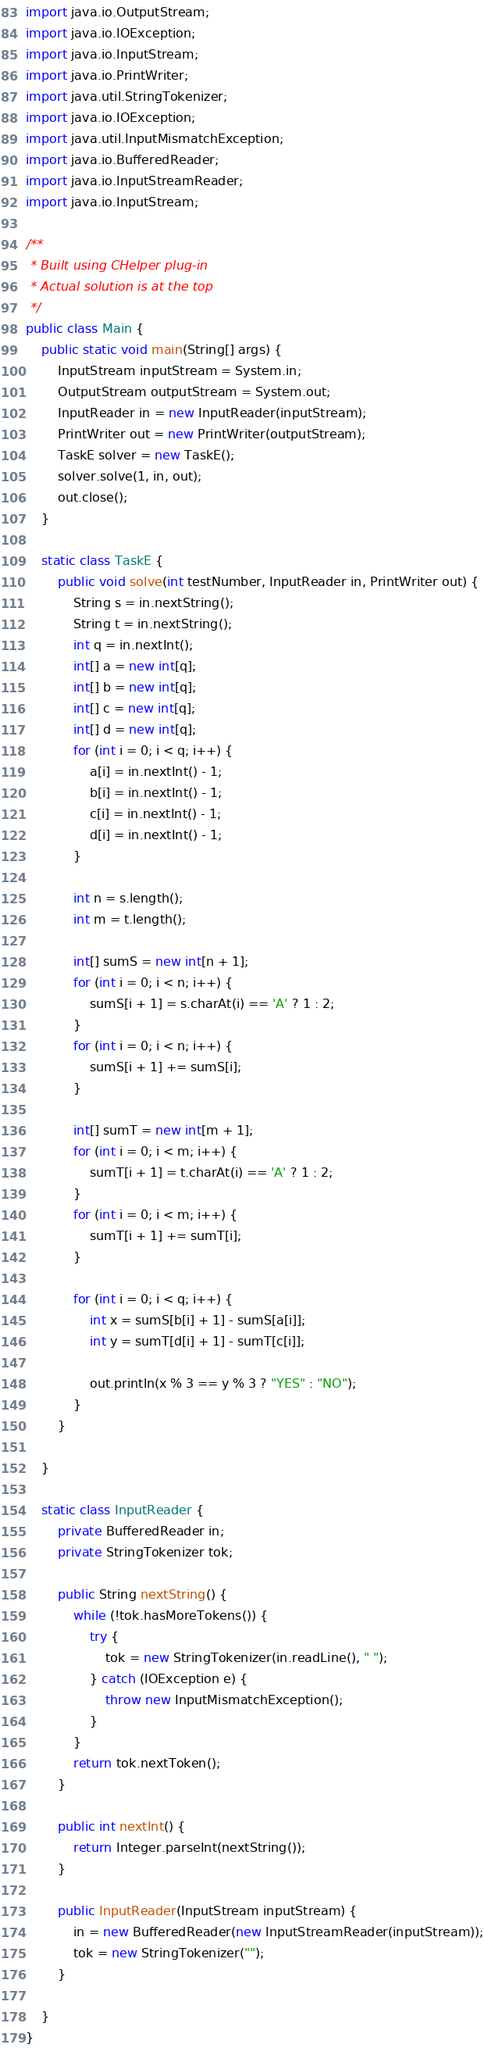<code> <loc_0><loc_0><loc_500><loc_500><_Java_>import java.io.OutputStream;
import java.io.IOException;
import java.io.InputStream;
import java.io.PrintWriter;
import java.util.StringTokenizer;
import java.io.IOException;
import java.util.InputMismatchException;
import java.io.BufferedReader;
import java.io.InputStreamReader;
import java.io.InputStream;

/**
 * Built using CHelper plug-in
 * Actual solution is at the top
 */
public class Main {
    public static void main(String[] args) {
        InputStream inputStream = System.in;
        OutputStream outputStream = System.out;
        InputReader in = new InputReader(inputStream);
        PrintWriter out = new PrintWriter(outputStream);
        TaskE solver = new TaskE();
        solver.solve(1, in, out);
        out.close();
    }

    static class TaskE {
        public void solve(int testNumber, InputReader in, PrintWriter out) {
            String s = in.nextString();
            String t = in.nextString();
            int q = in.nextInt();
            int[] a = new int[q];
            int[] b = new int[q];
            int[] c = new int[q];
            int[] d = new int[q];
            for (int i = 0; i < q; i++) {
                a[i] = in.nextInt() - 1;
                b[i] = in.nextInt() - 1;
                c[i] = in.nextInt() - 1;
                d[i] = in.nextInt() - 1;
            }

            int n = s.length();
            int m = t.length();

            int[] sumS = new int[n + 1];
            for (int i = 0; i < n; i++) {
                sumS[i + 1] = s.charAt(i) == 'A' ? 1 : 2;
            }
            for (int i = 0; i < n; i++) {
                sumS[i + 1] += sumS[i];
            }

            int[] sumT = new int[m + 1];
            for (int i = 0; i < m; i++) {
                sumT[i + 1] = t.charAt(i) == 'A' ? 1 : 2;
            }
            for (int i = 0; i < m; i++) {
                sumT[i + 1] += sumT[i];
            }

            for (int i = 0; i < q; i++) {
                int x = sumS[b[i] + 1] - sumS[a[i]];
                int y = sumT[d[i] + 1] - sumT[c[i]];

                out.println(x % 3 == y % 3 ? "YES" : "NO");
            }
        }

    }

    static class InputReader {
        private BufferedReader in;
        private StringTokenizer tok;

        public String nextString() {
            while (!tok.hasMoreTokens()) {
                try {
                    tok = new StringTokenizer(in.readLine(), " ");
                } catch (IOException e) {
                    throw new InputMismatchException();
                }
            }
            return tok.nextToken();
        }

        public int nextInt() {
            return Integer.parseInt(nextString());
        }

        public InputReader(InputStream inputStream) {
            in = new BufferedReader(new InputStreamReader(inputStream));
            tok = new StringTokenizer("");
        }

    }
}

</code> 